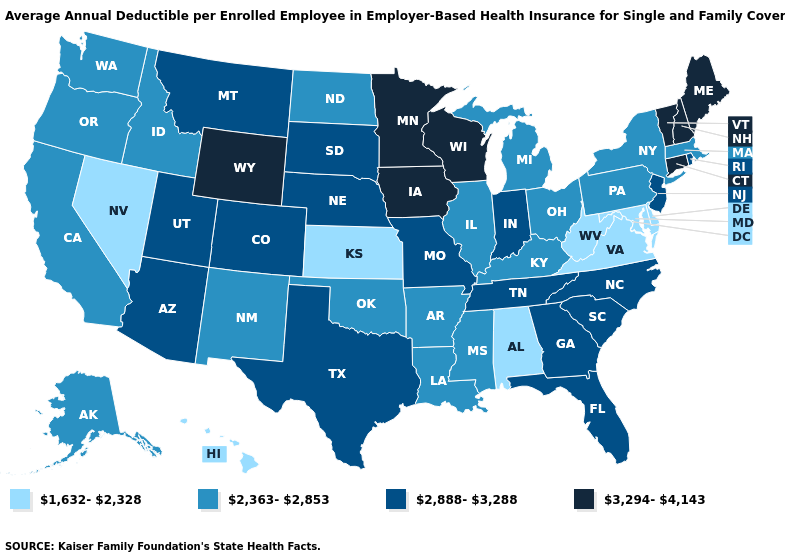What is the highest value in the Northeast ?
Short answer required. 3,294-4,143. Name the states that have a value in the range 1,632-2,328?
Give a very brief answer. Alabama, Delaware, Hawaii, Kansas, Maryland, Nevada, Virginia, West Virginia. What is the lowest value in states that border Connecticut?
Keep it brief. 2,363-2,853. Does the first symbol in the legend represent the smallest category?
Short answer required. Yes. What is the lowest value in the USA?
Be succinct. 1,632-2,328. Name the states that have a value in the range 1,632-2,328?
Give a very brief answer. Alabama, Delaware, Hawaii, Kansas, Maryland, Nevada, Virginia, West Virginia. Does Pennsylvania have the highest value in the Northeast?
Be succinct. No. Which states have the lowest value in the Northeast?
Keep it brief. Massachusetts, New York, Pennsylvania. Name the states that have a value in the range 2,363-2,853?
Write a very short answer. Alaska, Arkansas, California, Idaho, Illinois, Kentucky, Louisiana, Massachusetts, Michigan, Mississippi, New Mexico, New York, North Dakota, Ohio, Oklahoma, Oregon, Pennsylvania, Washington. Name the states that have a value in the range 3,294-4,143?
Quick response, please. Connecticut, Iowa, Maine, Minnesota, New Hampshire, Vermont, Wisconsin, Wyoming. What is the value of New York?
Give a very brief answer. 2,363-2,853. Does Minnesota have the lowest value in the MidWest?
Be succinct. No. Name the states that have a value in the range 2,888-3,288?
Quick response, please. Arizona, Colorado, Florida, Georgia, Indiana, Missouri, Montana, Nebraska, New Jersey, North Carolina, Rhode Island, South Carolina, South Dakota, Tennessee, Texas, Utah. Does Ohio have the same value as North Dakota?
Short answer required. Yes. Is the legend a continuous bar?
Quick response, please. No. 